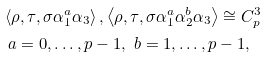Convert formula to latex. <formula><loc_0><loc_0><loc_500><loc_500>& \left \langle \rho , \tau , \sigma \alpha _ { 1 } ^ { a } \alpha _ { 3 } \right \rangle , \left \langle \rho , \tau , \sigma \alpha _ { 1 } ^ { a } \alpha _ { 2 } ^ { b } \alpha _ { 3 } \right \rangle \cong C _ { p } ^ { 3 } \\ & \ a = 0 , \dots , p - 1 , \ b = 1 , \dots , p - 1 ,</formula> 